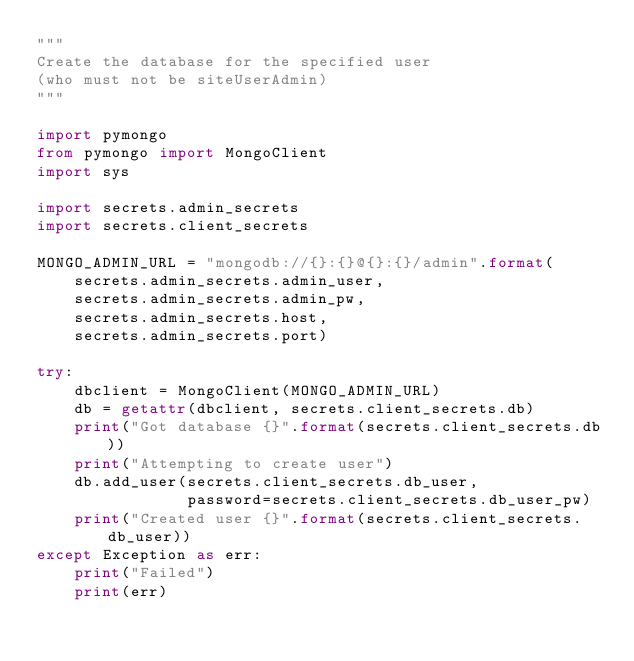Convert code to text. <code><loc_0><loc_0><loc_500><loc_500><_Python_>"""
Create the database for the specified user
(who must not be siteUserAdmin)
"""

import pymongo
from pymongo import MongoClient
import sys

import secrets.admin_secrets
import secrets.client_secrets

MONGO_ADMIN_URL = "mongodb://{}:{}@{}:{}/admin".format(
    secrets.admin_secrets.admin_user,
    secrets.admin_secrets.admin_pw,
    secrets.admin_secrets.host, 
    secrets.admin_secrets.port)

try: 
    dbclient = MongoClient(MONGO_ADMIN_URL)
    db = getattr(dbclient, secrets.client_secrets.db)
    print("Got database {}".format(secrets.client_secrets.db))
    print("Attempting to create user")
    db.add_user(secrets.client_secrets.db_user,
                password=secrets.client_secrets.db_user_pw)
    print("Created user {}".format(secrets.client_secrets.db_user))
except Exception as err:
    print("Failed")
    print(err)</code> 